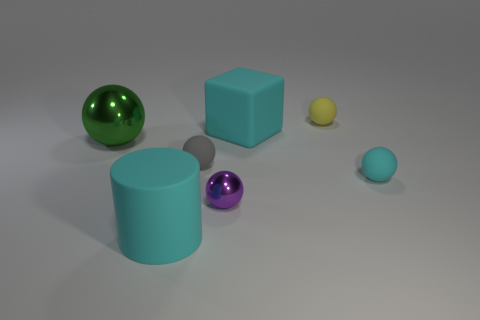What number of things are small purple metal things or big cyan rubber things behind the rubber cylinder?
Your answer should be very brief. 2. Is there a purple metal thing that has the same shape as the small cyan rubber object?
Ensure brevity in your answer.  Yes. There is a matte sphere to the left of the object behind the big cube; how big is it?
Provide a short and direct response. Small. Is the color of the cylinder the same as the big block?
Your answer should be very brief. Yes. What number of rubber things are big green objects or cyan cylinders?
Provide a short and direct response. 1. How many tiny spheres are there?
Keep it short and to the point. 4. Do the small sphere that is behind the large cyan rubber block and the large thing behind the big ball have the same material?
Ensure brevity in your answer.  Yes. There is another small shiny thing that is the same shape as the green metallic thing; what is its color?
Your answer should be compact. Purple. What is the material of the cyan object to the left of the large matte object on the right side of the purple ball?
Your answer should be very brief. Rubber. Is the shape of the tiny object that is behind the gray matte ball the same as the tiny thing to the right of the small yellow matte sphere?
Make the answer very short. Yes. 